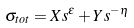Convert formula to latex. <formula><loc_0><loc_0><loc_500><loc_500>\sigma _ { t o t } = X s ^ { \epsilon } + Y s ^ { - \eta }</formula> 